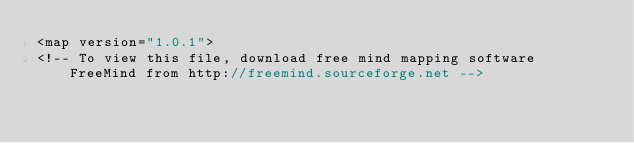<code> <loc_0><loc_0><loc_500><loc_500><_ObjectiveC_><map version="1.0.1">
<!-- To view this file, download free mind mapping software FreeMind from http://freemind.sourceforge.net --></code> 